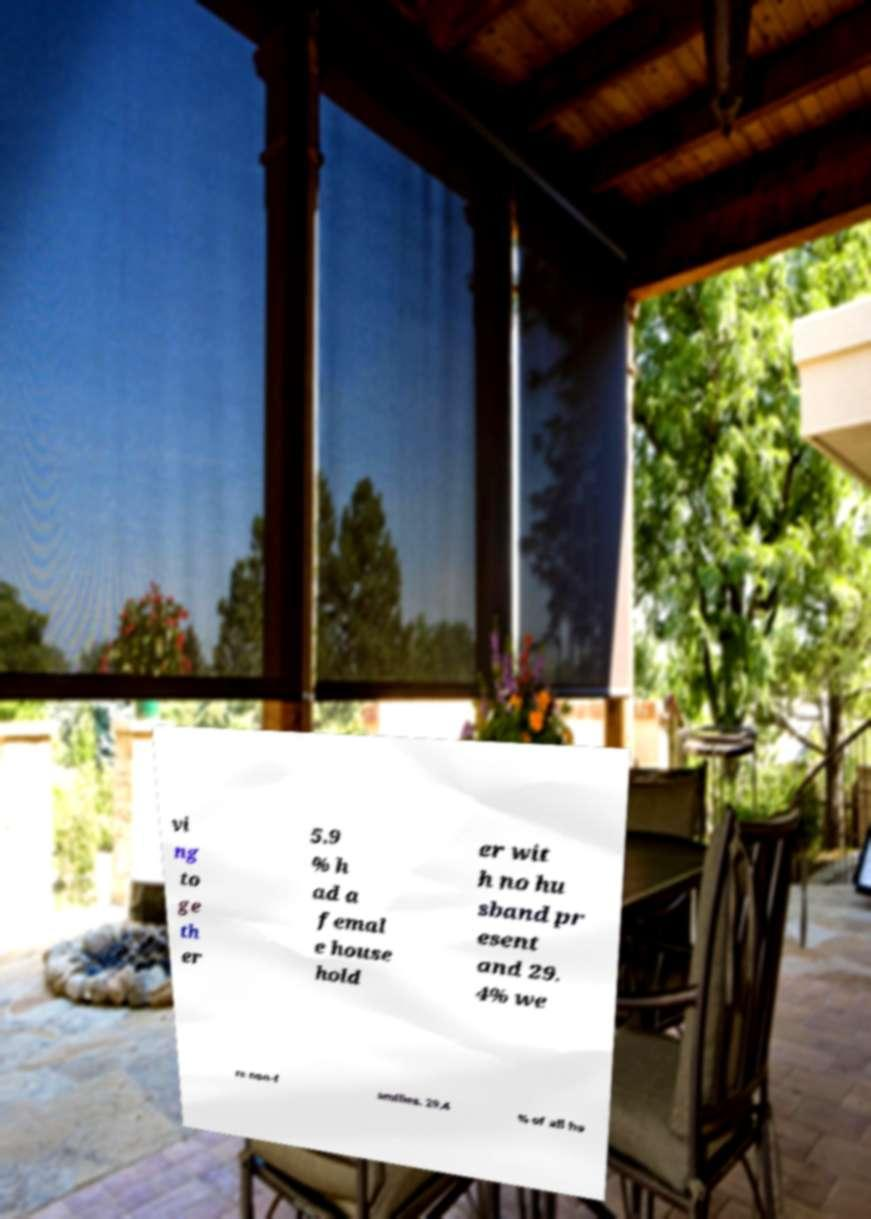Can you read and provide the text displayed in the image?This photo seems to have some interesting text. Can you extract and type it out for me? vi ng to ge th er 5.9 % h ad a femal e house hold er wit h no hu sband pr esent and 29. 4% we re non-f amilies. 29.4 % of all ho 